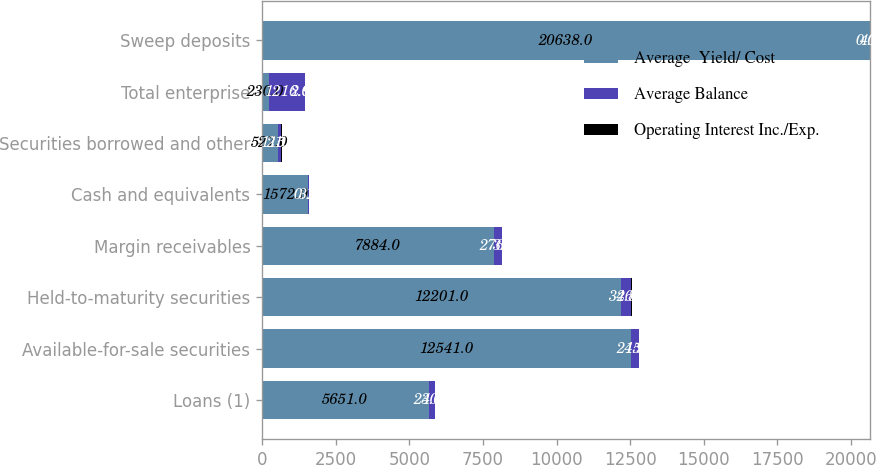<chart> <loc_0><loc_0><loc_500><loc_500><stacked_bar_chart><ecel><fcel>Loans (1)<fcel>Available-for-sale securities<fcel>Held-to-maturity securities<fcel>Margin receivables<fcel>Cash and equivalents<fcel>Securities borrowed and other<fcel>Total enterprise<fcel>Sweep deposits<nl><fcel>Average  Yield/ Cost<fcel>5651<fcel>12541<fcel>12201<fcel>7884<fcel>1572<fcel>527<fcel>230<fcel>20638<nl><fcel>Average Balance<fcel>230<fcel>245<fcel>346<fcel>276<fcel>3<fcel>115<fcel>1216<fcel>4<nl><fcel>Operating Interest Inc./Exp.<fcel>4.06<fcel>1.95<fcel>2.84<fcel>3.5<fcel>0.19<fcel>21.9<fcel>2.98<fcel>0.02<nl></chart> 